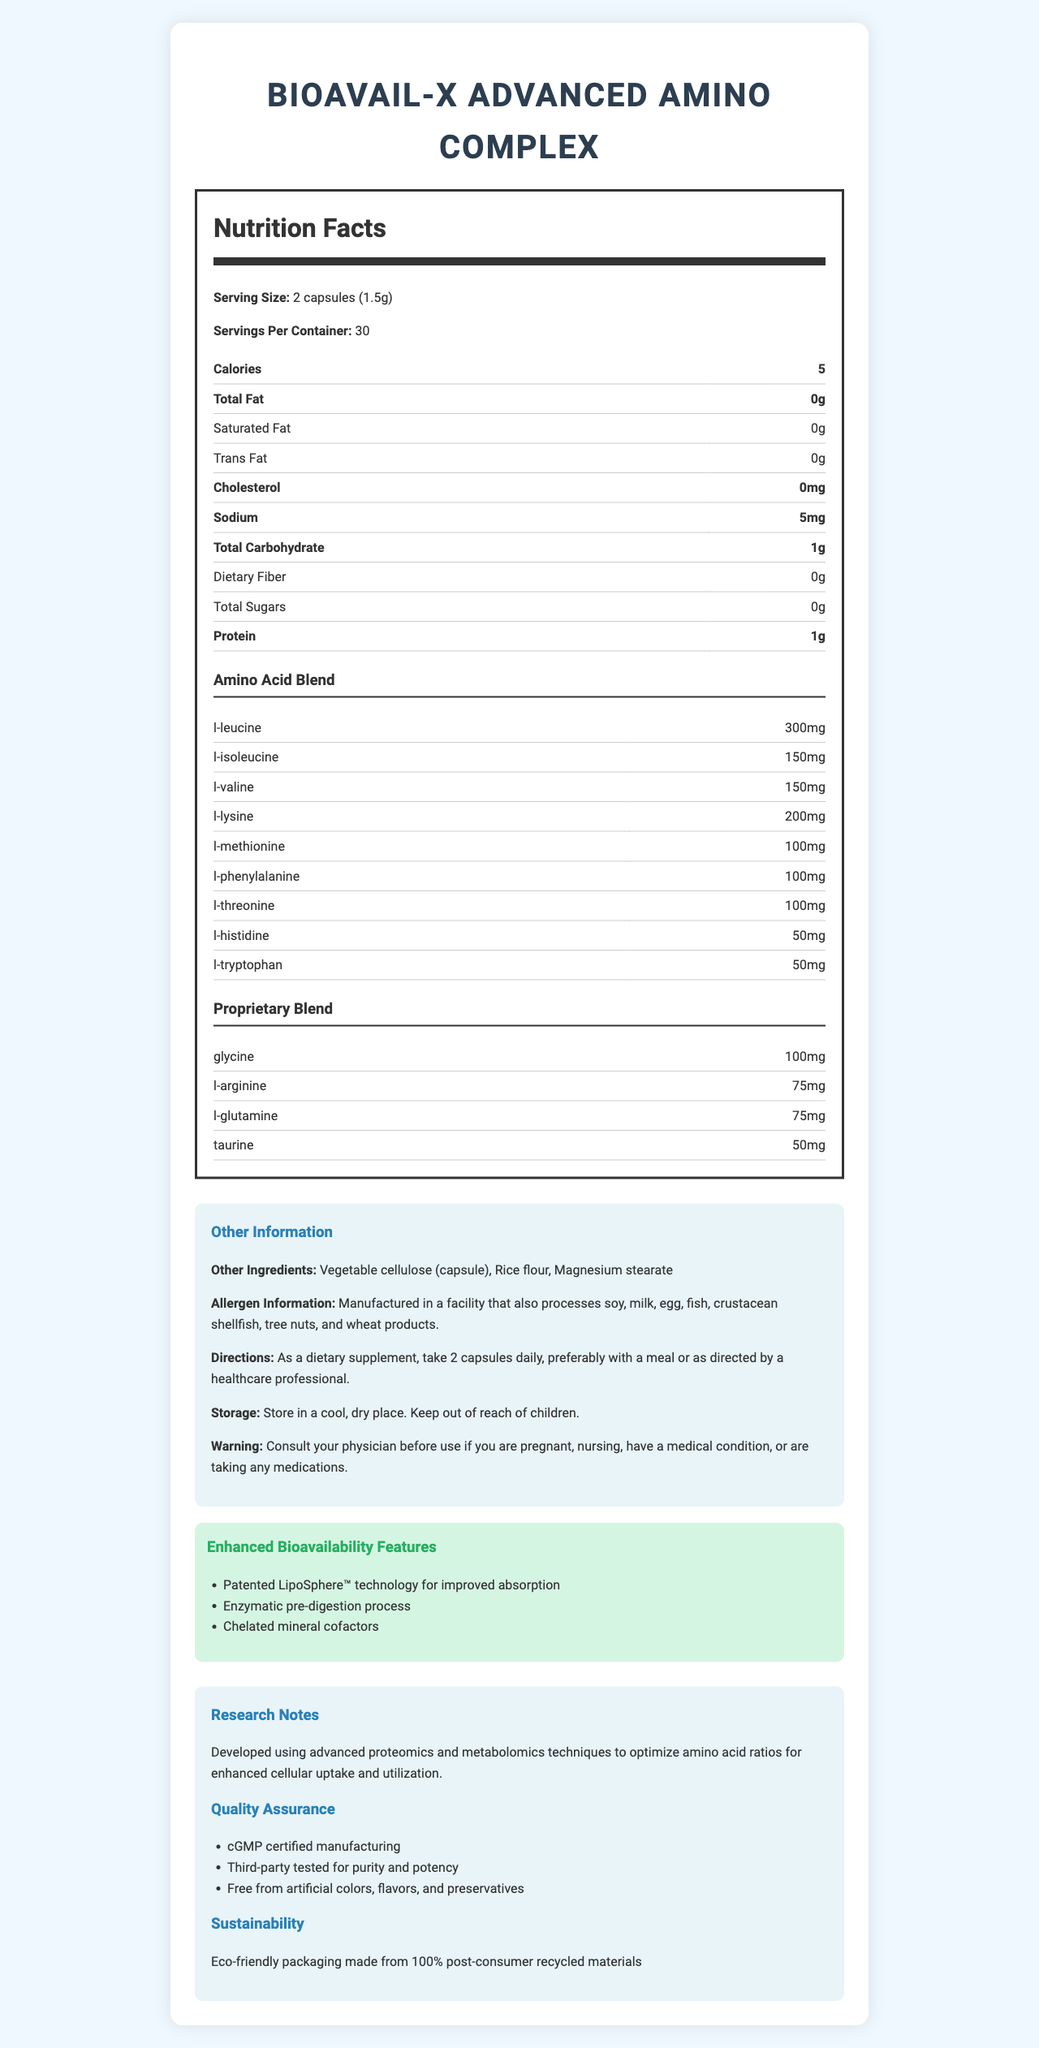how many calories are in a serving of BioAvail-X Advanced Amino Complex? The Nutrition Facts section states that there are 5 calories per serving.
Answer: 5 what is the serving size of BioAvail-X Advanced Amino Complex? The serving size is clearly mentioned as "2 capsules (1.5g)".
Answer: 2 capsules (1.5g) how much protein does a serving contain? The Nutrition Facts section indicates that each serving contains 1 gram of protein.
Answer: 1 gram what is the purpose of the LipoSphere™ technology mentioned in the document? The document mentions that LipoSphere™ technology is used for improved absorption.
Answer: improved absorption name one of the quality assurance measures mentioned. One of the quality assurance measures provided is that the product is third-party tested for purity and potency.
Answer: Third-party tested for purity and potency how much L-Leucine is in each serving? The Amino Acid Blend section states that there are 300 mg of L-Leucine in each serving.
Answer: 300 mg how many servings are in one container of BioAvail-X Advanced Amino Complex? The document specifies that there are 30 servings per container.
Answer: 30 which amino acid is present in the smallest amount in the proprietary blend? A. Glycine B. L-Arginine C. L-Glutamine D. Taurine The Proprietary Blend section states that Taurine is present in the smallest amount, at 50 mg.
Answer: D. Taurine how much L-Isoleucine does the supplement contain per serving? A. 150 mg B. 300 mg C. 200 mg D. 100 mg The Amino Acid Blend section shows that L-Isoleucine is present in 150 mg per serving.
Answer: A. 150 mg does BioAvail-X Advanced Amino Complex contain iron? According to the Nutrition Facts, the product contains 0 mg of iron.
Answer: No is BioAvail-X Advanced Amino Complex free from artificial colors, flavors, and preservatives? The Quality Assurance section states that the product is free from artificial colors, flavors, and preservatives.
Answer: Yes summarize the key features and composition of BioAvail-X Advanced Amino Complex. The document provides detailed information about the enhanced bioavailability features, composition, serving size, quality assurance, and other ingredients of the BioAvail-X Advanced Amino Complex.
Answer: BioAvail-X Advanced Amino Complex is a dietary supplement with enhanced bioavailability due to patented LipoSphere™ technology, enzymatic pre-digestion process, and chelated mineral cofactors. Each serving of 2 capsules contains an amino acid blend, a proprietary blend, and it is third-party tested for purity and potency. The product is also free from artificial colors, flavors, and preservatives, and it is manufactured in a cGMP certified facility. what advanced techniques are mentioned in the research notes that were used to optimize the amino acid ratios? The Research Notes section states that advanced proteomics and metabolomics techniques were used.
Answer: proteomics and metabolomics identify an ingredient indicated as a potential allergen. The allergen information states that the product is manufactured in a facility that processes soy.
Answer: soy what is the recommended way to take BioAvail-X Advanced Amino Complex? The Directions section specifies taking 2 capsules daily, preferably with a meal.
Answer: take 2 capsules daily, preferably with a meal does the document provide information about possible side effects? The document does not list specific side effects; it only includes a warning to consult a physician before use.
Answer: No how is BioAvail-X Advanced Amino Complex eco-friendly? The document mentions that the product has eco-friendly packaging made from 100% post-consumer recycled materials.
Answer: Eco-friendly packaging made from 100% post-consumer recycled materials does the supplement contain any calories from fat? According to the Nutrition Facts, the supplement contains 0 calories from fat.
Answer: No what process is mentioned to improve the cellular uptake of amino acids? The document mentions an enzymatic pre-digestion process to enhance cellular uptake and utilization.
Answer: enzymatic pre-digestion process how much sodium is there per serving of BioAvail-X Advanced Amino Complex? The Nutrition Facts section indicates that there are 5 mg of sodium per serving.
Answer: 5 mg 